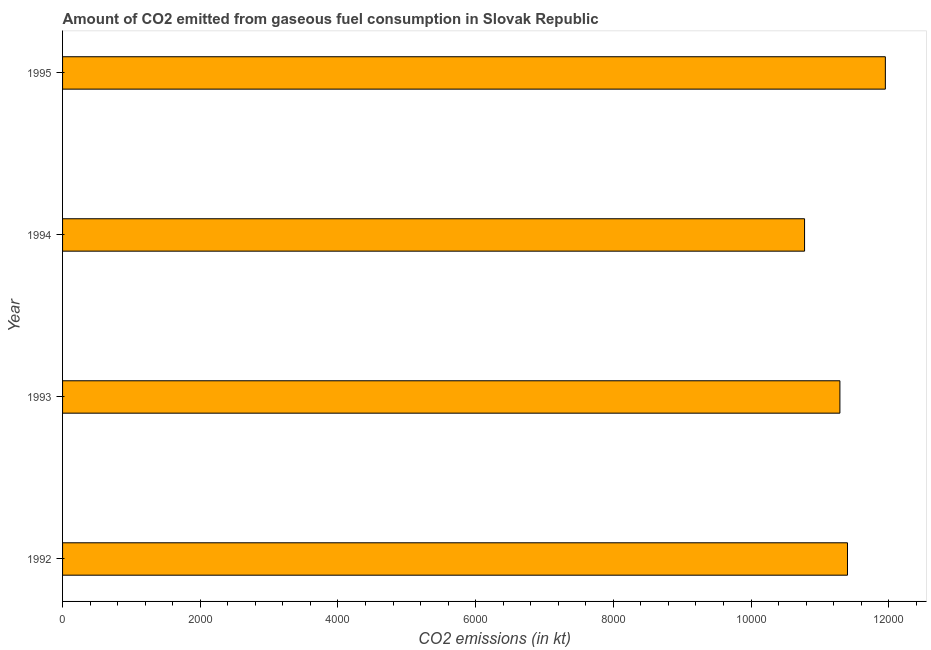What is the title of the graph?
Make the answer very short. Amount of CO2 emitted from gaseous fuel consumption in Slovak Republic. What is the label or title of the X-axis?
Make the answer very short. CO2 emissions (in kt). What is the label or title of the Y-axis?
Keep it short and to the point. Year. What is the co2 emissions from gaseous fuel consumption in 1993?
Provide a succinct answer. 1.13e+04. Across all years, what is the maximum co2 emissions from gaseous fuel consumption?
Offer a terse response. 1.20e+04. Across all years, what is the minimum co2 emissions from gaseous fuel consumption?
Offer a very short reply. 1.08e+04. In which year was the co2 emissions from gaseous fuel consumption maximum?
Ensure brevity in your answer.  1995. What is the sum of the co2 emissions from gaseous fuel consumption?
Offer a very short reply. 4.54e+04. What is the difference between the co2 emissions from gaseous fuel consumption in 1993 and 1995?
Provide a short and direct response. -660.06. What is the average co2 emissions from gaseous fuel consumption per year?
Provide a succinct answer. 1.14e+04. What is the median co2 emissions from gaseous fuel consumption?
Provide a succinct answer. 1.13e+04. Do a majority of the years between 1995 and 1994 (inclusive) have co2 emissions from gaseous fuel consumption greater than 6800 kt?
Your answer should be compact. No. What is the ratio of the co2 emissions from gaseous fuel consumption in 1992 to that in 1994?
Your response must be concise. 1.06. Is the difference between the co2 emissions from gaseous fuel consumption in 1994 and 1995 greater than the difference between any two years?
Make the answer very short. Yes. What is the difference between the highest and the second highest co2 emissions from gaseous fuel consumption?
Offer a terse response. 550.05. Is the sum of the co2 emissions from gaseous fuel consumption in 1993 and 1995 greater than the maximum co2 emissions from gaseous fuel consumption across all years?
Your answer should be very brief. Yes. What is the difference between the highest and the lowest co2 emissions from gaseous fuel consumption?
Your answer should be very brief. 1173.44. How many bars are there?
Provide a succinct answer. 4. Are the values on the major ticks of X-axis written in scientific E-notation?
Your answer should be very brief. No. What is the CO2 emissions (in kt) in 1992?
Your answer should be very brief. 1.14e+04. What is the CO2 emissions (in kt) in 1993?
Your response must be concise. 1.13e+04. What is the CO2 emissions (in kt) of 1994?
Provide a succinct answer. 1.08e+04. What is the CO2 emissions (in kt) in 1995?
Provide a succinct answer. 1.20e+04. What is the difference between the CO2 emissions (in kt) in 1992 and 1993?
Offer a very short reply. 110.01. What is the difference between the CO2 emissions (in kt) in 1992 and 1994?
Provide a succinct answer. 623.39. What is the difference between the CO2 emissions (in kt) in 1992 and 1995?
Keep it short and to the point. -550.05. What is the difference between the CO2 emissions (in kt) in 1993 and 1994?
Provide a short and direct response. 513.38. What is the difference between the CO2 emissions (in kt) in 1993 and 1995?
Provide a succinct answer. -660.06. What is the difference between the CO2 emissions (in kt) in 1994 and 1995?
Offer a very short reply. -1173.44. What is the ratio of the CO2 emissions (in kt) in 1992 to that in 1993?
Your answer should be compact. 1.01. What is the ratio of the CO2 emissions (in kt) in 1992 to that in 1994?
Your answer should be very brief. 1.06. What is the ratio of the CO2 emissions (in kt) in 1992 to that in 1995?
Offer a very short reply. 0.95. What is the ratio of the CO2 emissions (in kt) in 1993 to that in 1994?
Your answer should be compact. 1.05. What is the ratio of the CO2 emissions (in kt) in 1993 to that in 1995?
Provide a short and direct response. 0.94. What is the ratio of the CO2 emissions (in kt) in 1994 to that in 1995?
Make the answer very short. 0.9. 